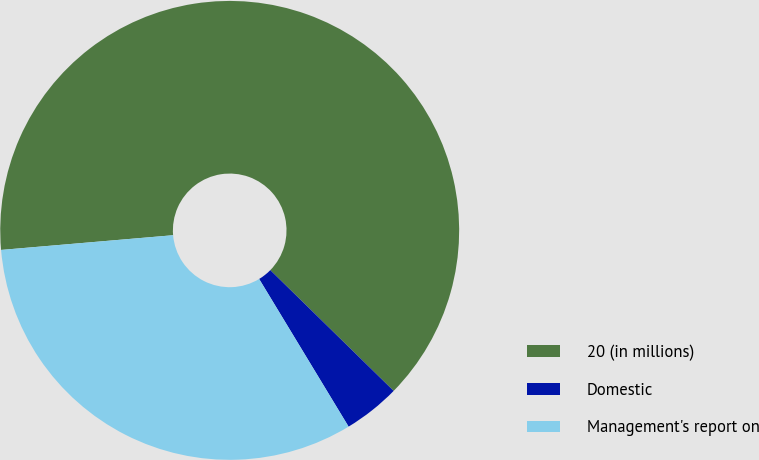Convert chart. <chart><loc_0><loc_0><loc_500><loc_500><pie_chart><fcel>20 (in millions)<fcel>Domestic<fcel>Management's report on<nl><fcel>63.69%<fcel>4.0%<fcel>32.31%<nl></chart> 